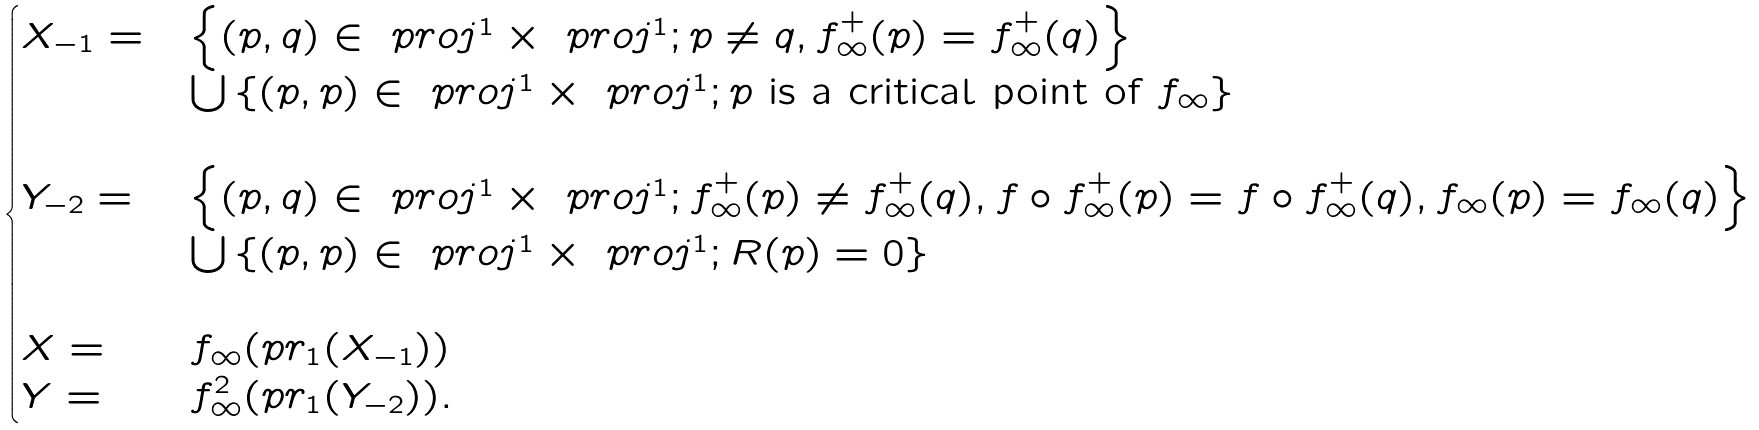<formula> <loc_0><loc_0><loc_500><loc_500>\begin{cases} X _ { - 1 } = & \left \{ ( p , q ) \in \ p r o j ^ { 1 } \times \ p r o j ^ { 1 } ; p \neq q , f _ { \infty } ^ { + } ( p ) = f _ { \infty } ^ { + } ( q ) \right \} \\ & \bigcup \left \{ ( p , p ) \in \ p r o j ^ { 1 } \times \ p r o j ^ { 1 } ; p \text { is a critical point of } f _ { \infty } \right \} \\ \\ Y _ { - 2 } = & \left \{ ( p , q ) \in \ p r o j ^ { 1 } \times \ p r o j ^ { 1 } ; f _ { \infty } ^ { + } ( p ) \neq f _ { \infty } ^ { + } ( q ) , f \circ f _ { \infty } ^ { + } ( p ) = f \circ f _ { \infty } ^ { + } ( q ) , f _ { \infty } ( p ) = f _ { \infty } ( q ) \right \} \\ & \bigcup \left \{ ( p , p ) \in \ p r o j ^ { 1 } \times \ p r o j ^ { 1 } ; R ( p ) = 0 \right \} \\ \\ X = & f _ { \infty } ( p r _ { 1 } ( X _ { - 1 } ) ) \\ Y = & f ^ { 2 } _ { \infty } ( p r _ { 1 } ( Y _ { - 2 } ) ) . \end{cases}</formula> 